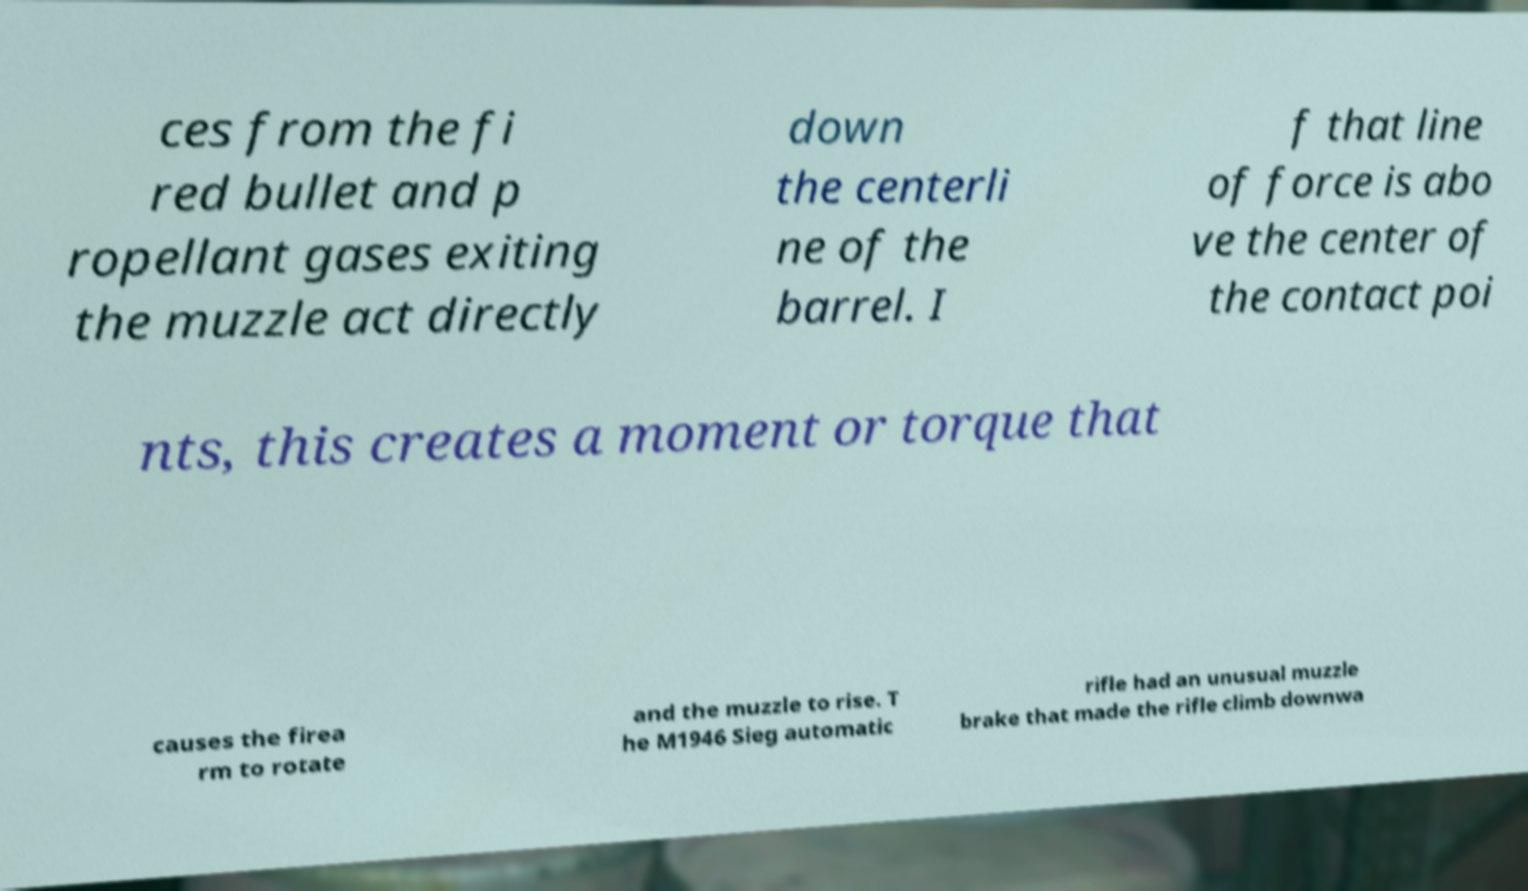For documentation purposes, I need the text within this image transcribed. Could you provide that? ces from the fi red bullet and p ropellant gases exiting the muzzle act directly down the centerli ne of the barrel. I f that line of force is abo ve the center of the contact poi nts, this creates a moment or torque that causes the firea rm to rotate and the muzzle to rise. T he M1946 Sieg automatic rifle had an unusual muzzle brake that made the rifle climb downwa 